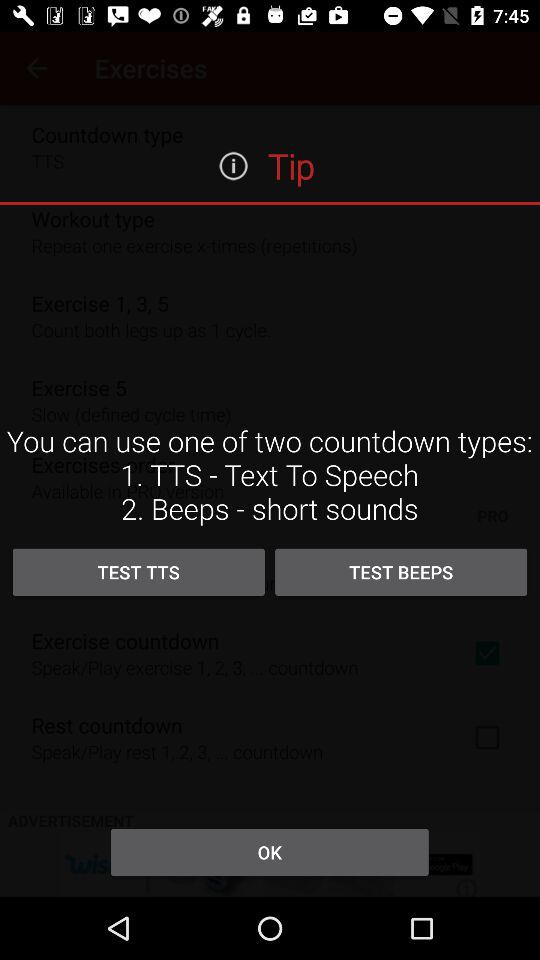How many countdown types are available?
Answer the question using a single word or phrase. 2 